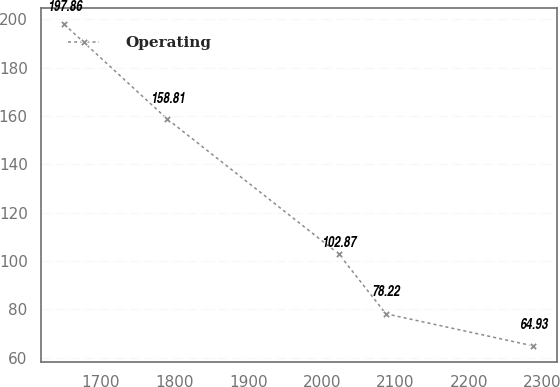Convert chart to OTSL. <chart><loc_0><loc_0><loc_500><loc_500><line_chart><ecel><fcel>Operating<nl><fcel>1650.24<fcel>197.86<nl><fcel>1789.82<fcel>158.81<nl><fcel>2023.28<fcel>102.87<nl><fcel>2086.98<fcel>78.22<nl><fcel>2287.26<fcel>64.93<nl></chart> 